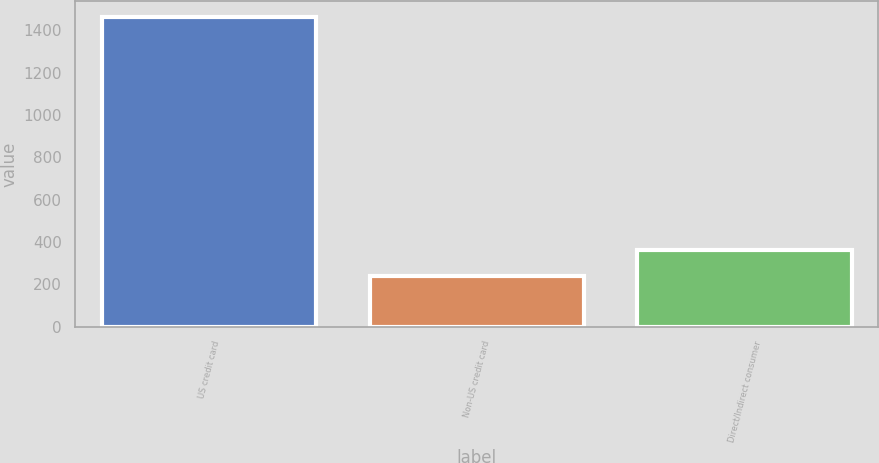<chart> <loc_0><loc_0><loc_500><loc_500><bar_chart><fcel>US credit card<fcel>Non-US credit card<fcel>Direct/Indirect consumer<nl><fcel>1465<fcel>240<fcel>362.5<nl></chart> 